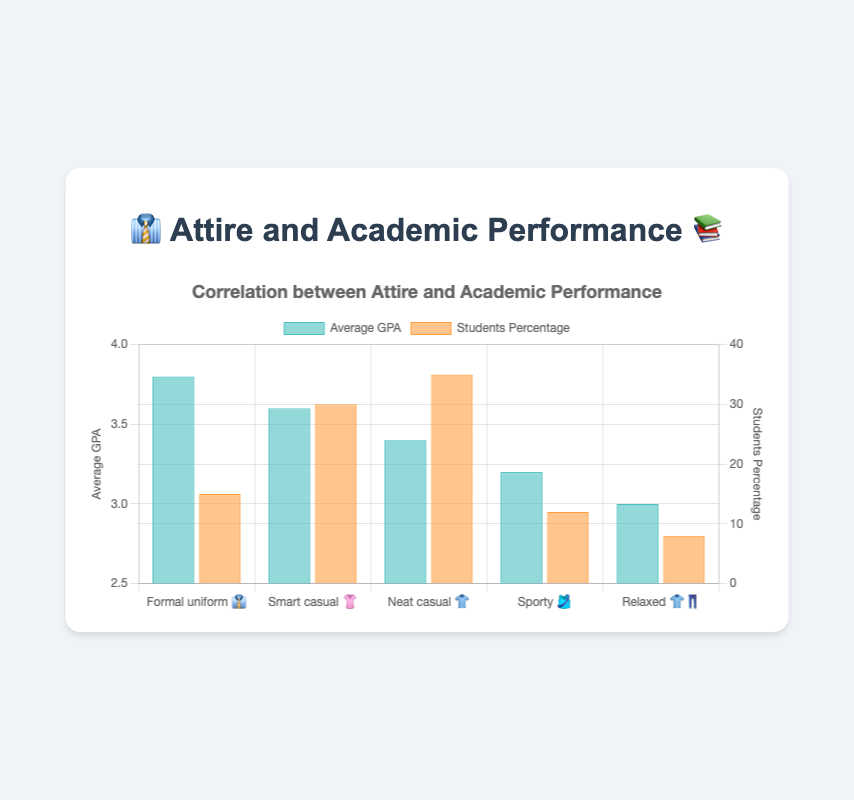What is the highest average GPA among the different attires? The highest average GPA can be identified by looking at the tallest bar in the 'Average GPA' dataset. This corresponds to the 'Formal uniform 👔' attire.
Answer: 3.8 Which attire has the lowest percentage of students? To find this, look at the 'Students Percentage' dataset and identify the shortest bar. This corresponds to the 'Relaxed 👕👖' attire.
Answer: 8% What is the average of the GPAs for all attires combined? To calculate this, sum all the average GPA values (3.8 + 3.6 + 3.4 + 3.2 + 3.0) and then divide by the number of attires (5). The calculation is (3.8 + 3.6 + 3.4 + 3.2 + 3.0) / 5 = 3.4
Answer: 3.4 Which attire has both the highest average GPA and the highest students percentage? By looking at both datasets, the 'Formal uniform 👔' has the highest average GPA, but the 'Neat casual 👕' has the highest students percentage. Therefore, no single attire holds both the highest GPA and the highest students percentage.
Answer: None How does the average GPA of 'Sporty 🎽' attire compare to that of 'Smart casual 👚'? Compare the average GPA values: 'Smart casual 👚' has a GPA of 3.6, while 'Sporty 🎽' has a GPA of 3.2. The 'Smart casual 👚' attire has a higher average GPA.
Answer: Smart casual 👚 Which two attires have the closest average GPAs? By observing the 'Average GPA' values, 'Neat casual 👕' (3.4) and 'Smart casual 👚' (3.6) seem closest. Their difference is 0.2.
Answer: Neat casual 👕 and Smart casual 👚 What percentage of students dressed in 'Smart casual 👚' attire? Refer to the 'Students Percentage' dataset and look for the value corresponding to 'Smart casual 👚'.
Answer: 30% If we combine the percentage of students wearing 'Neat casual 👕' and 'Sporty 🎽', what is the total? Add the percentages of students wearing 'Neat casual 👕' (35%) and 'Sporty 🎽' (12%): 35 + 12 = 47%.
Answer: 47% What is the title of the chart? The title is displayed at the top of the chart.
Answer: Correlation between Attire and Academic Performance Is there a correlation between being well-dressed and having a higher GPA based on the chart? Observing the chart, attires considered more formal like 'Formal uniform 👔' have higher average GPAs compared to more casual ones like 'Relaxed 👕👖', indicating a possible correlation.
Answer: Yes 